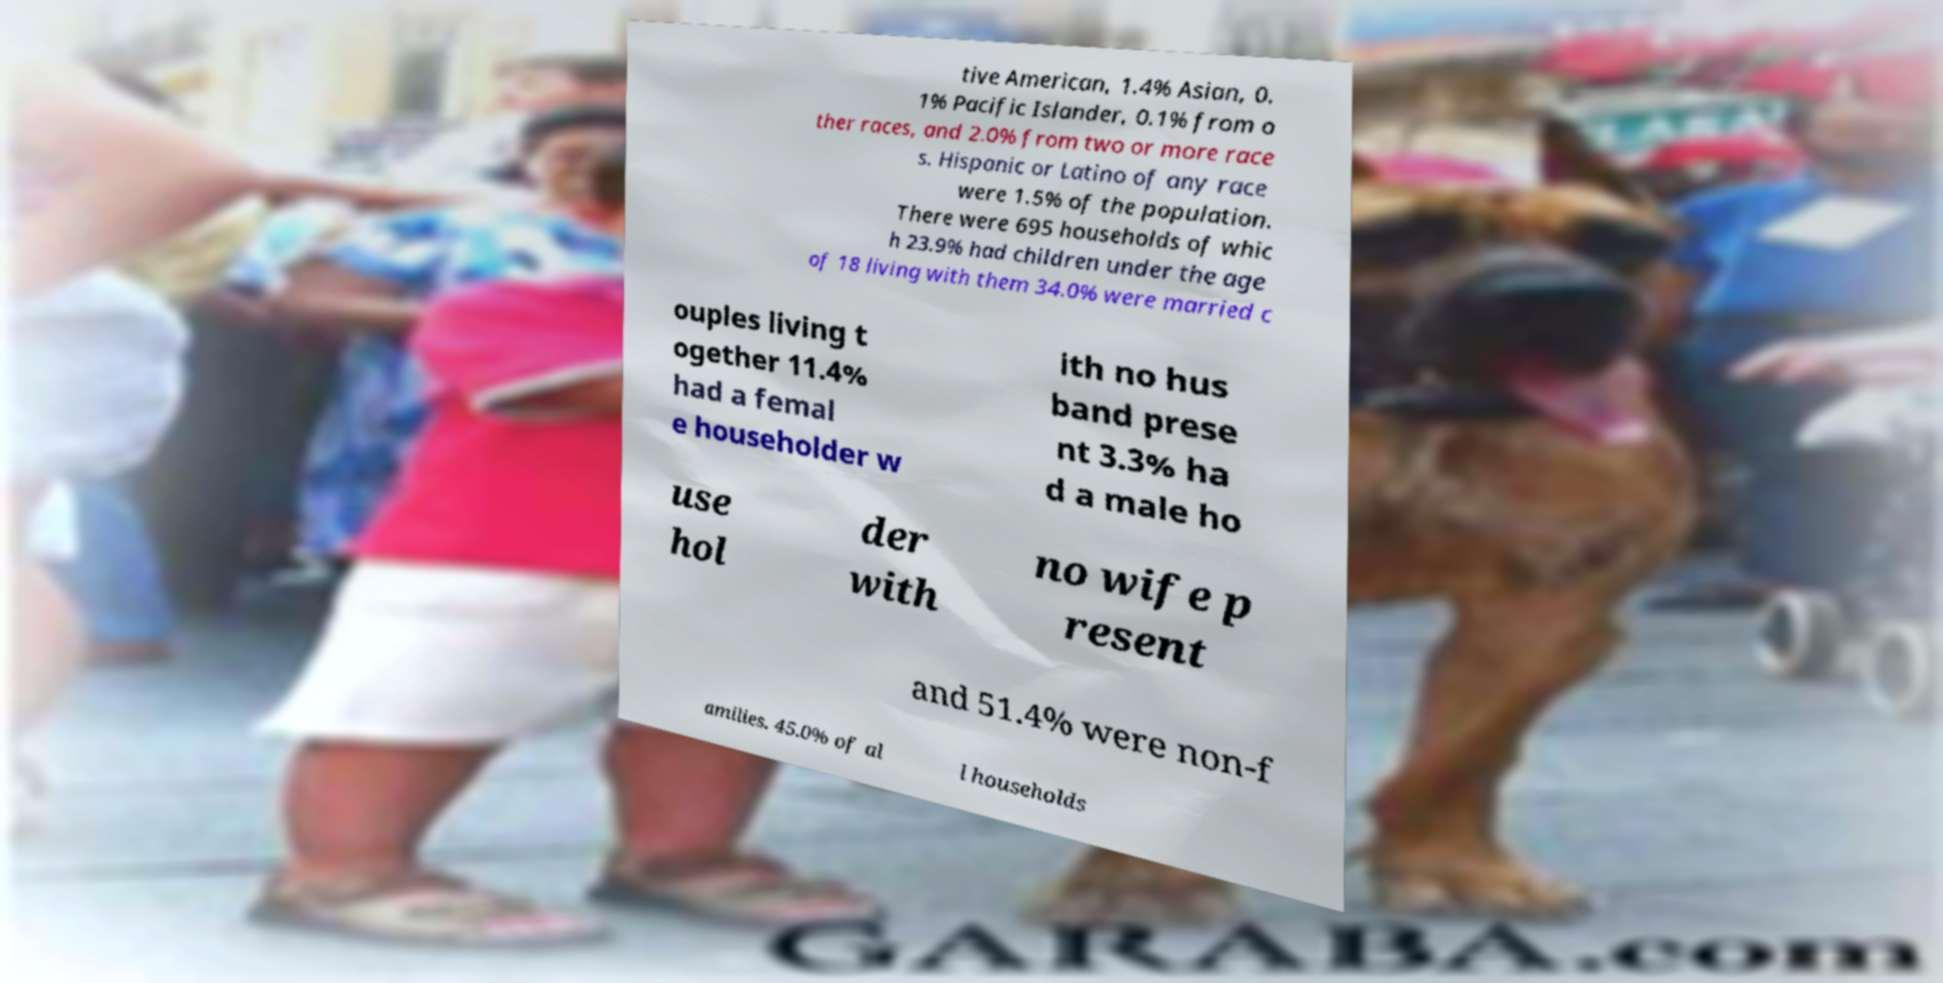Could you assist in decoding the text presented in this image and type it out clearly? tive American, 1.4% Asian, 0. 1% Pacific Islander, 0.1% from o ther races, and 2.0% from two or more race s. Hispanic or Latino of any race were 1.5% of the population. There were 695 households of whic h 23.9% had children under the age of 18 living with them 34.0% were married c ouples living t ogether 11.4% had a femal e householder w ith no hus band prese nt 3.3% ha d a male ho use hol der with no wife p resent and 51.4% were non-f amilies. 45.0% of al l households 